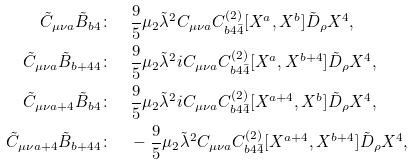Convert formula to latex. <formula><loc_0><loc_0><loc_500><loc_500>\tilde { C } _ { \mu \nu a } \tilde { B } _ { b 4 } & \colon \quad \frac { 9 } { 5 } \mu _ { 2 } \tilde { \lambda } ^ { 2 } C _ { \mu \nu a } C ^ { ( 2 ) } _ { b 4 \bar { 4 } } [ X ^ { a } , X ^ { b } ] \tilde { D } _ { \rho } X ^ { 4 } , \\ \tilde { C } _ { \mu \nu a } \tilde { B } _ { b + 4 4 } & \colon \quad \frac { 9 } { 5 } \mu _ { 2 } \tilde { \lambda } ^ { 2 } i C _ { \mu \nu a } C ^ { ( 2 ) } _ { b 4 \bar { 4 } } [ X ^ { a } , X ^ { b + 4 } ] \tilde { D } _ { \rho } X ^ { 4 } , \\ \tilde { C } _ { \mu \nu a + 4 } \tilde { B } _ { b 4 } & \colon \quad \frac { 9 } { 5 } \mu _ { 2 } \tilde { \lambda } ^ { 2 } i C _ { \mu \nu a } C ^ { ( 2 ) } _ { b 4 \bar { 4 } } [ X ^ { a + 4 } , X ^ { b } ] \tilde { D } _ { \rho } X ^ { 4 } , \\ \tilde { C } _ { \mu \nu a + 4 } \tilde { B } _ { b + 4 4 } & \colon \quad - \frac { 9 } { 5 } \mu _ { 2 } \tilde { \lambda } ^ { 2 } C _ { \mu \nu a } C ^ { ( 2 ) } _ { b 4 \bar { 4 } } [ X ^ { a + 4 } , X ^ { b + 4 } ] \tilde { D } _ { \rho } X ^ { 4 } ,</formula> 